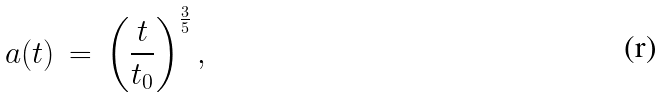<formula> <loc_0><loc_0><loc_500><loc_500>a ( t ) \, = \, \left ( \frac { t } { t _ { 0 } } \right ) ^ { \frac { 3 } { 5 } } ,</formula> 